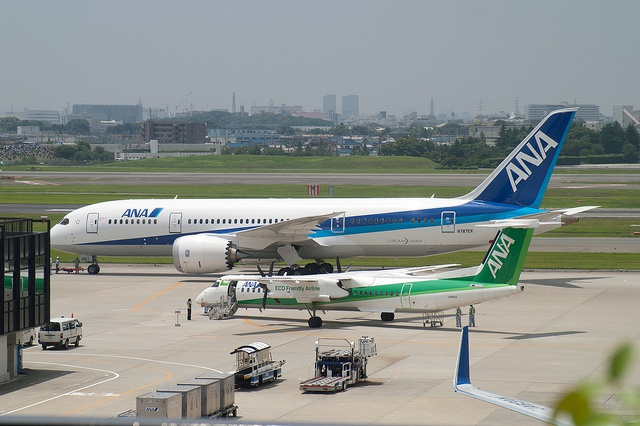Describe the objects in this image and their specific colors. I can see airplane in darkgray, white, gray, and navy tones, airplane in darkgray, lightgray, darkgreen, and gray tones, truck in darkgray, black, and gray tones, truck in darkgray, black, gray, and lightgray tones, and car in darkgray, black, and gray tones in this image. 